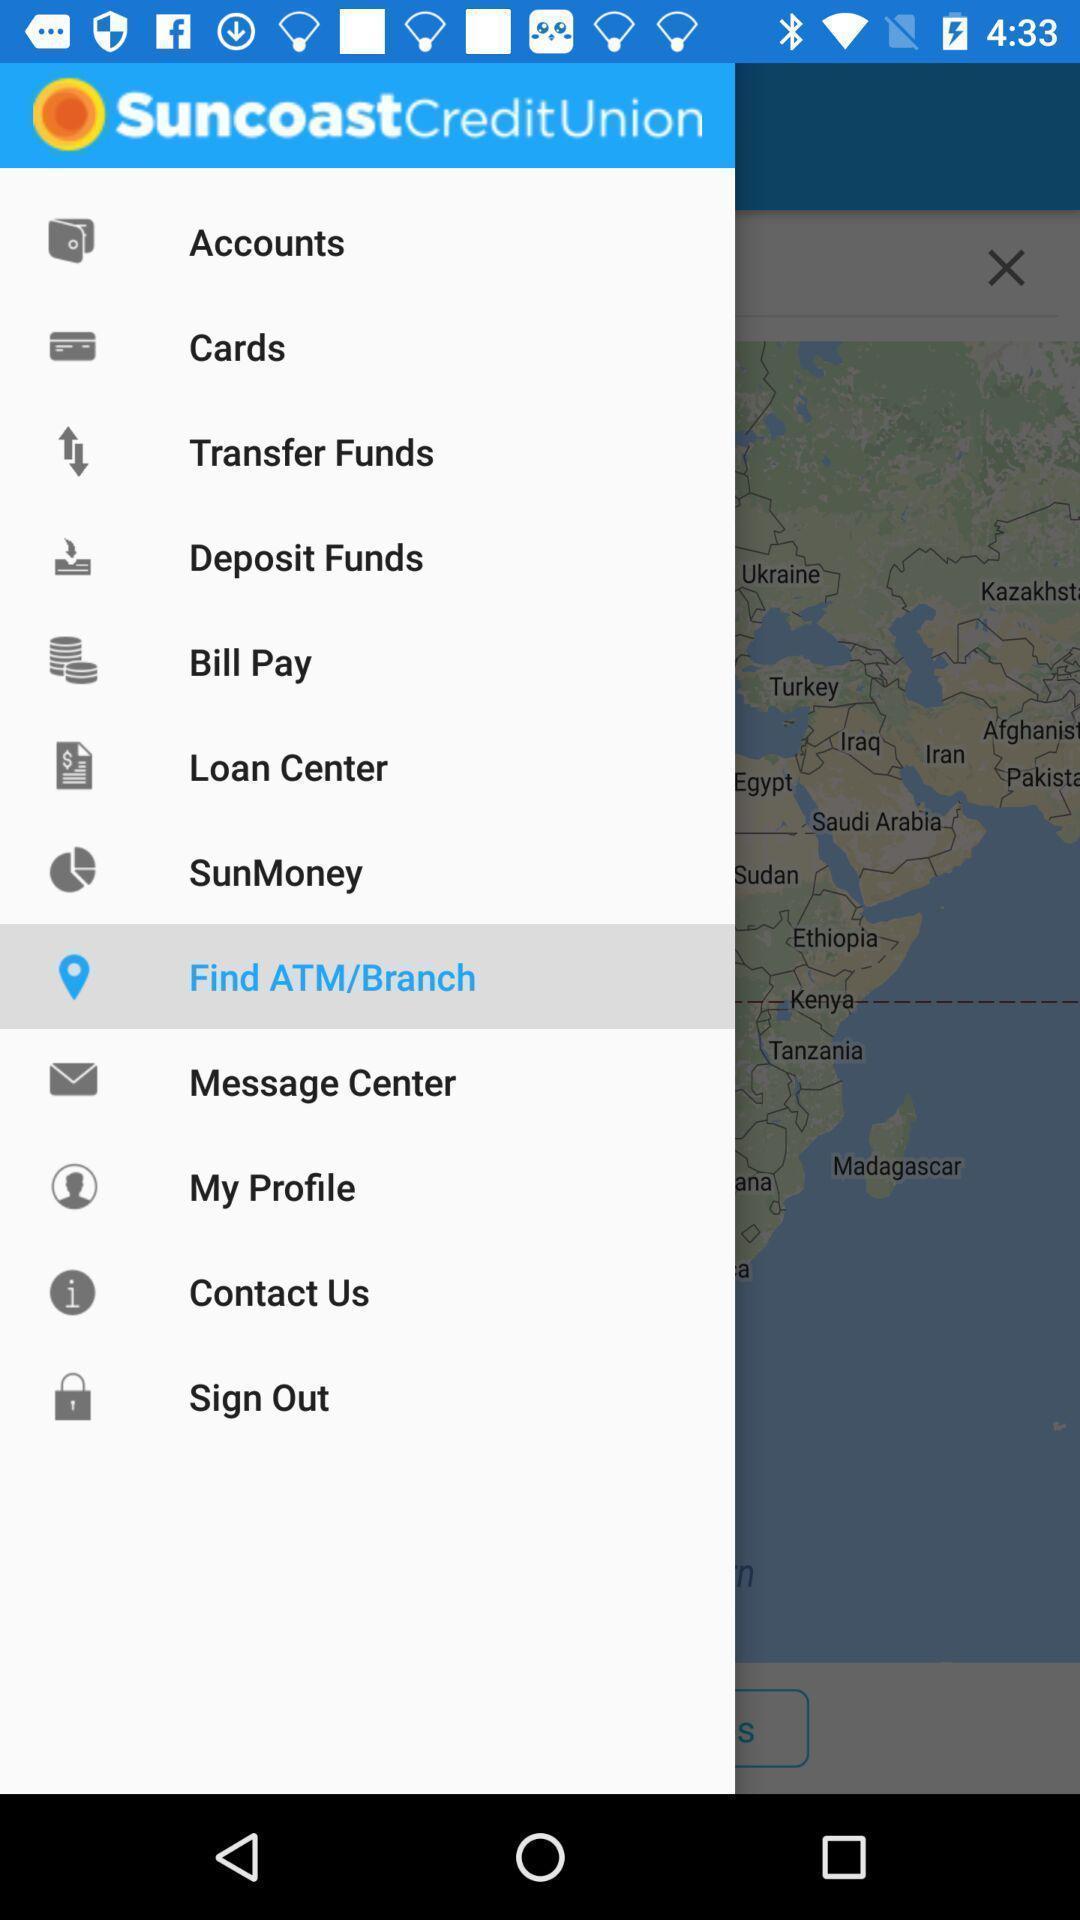Give me a summary of this screen capture. Window displaying the page of financial app. 